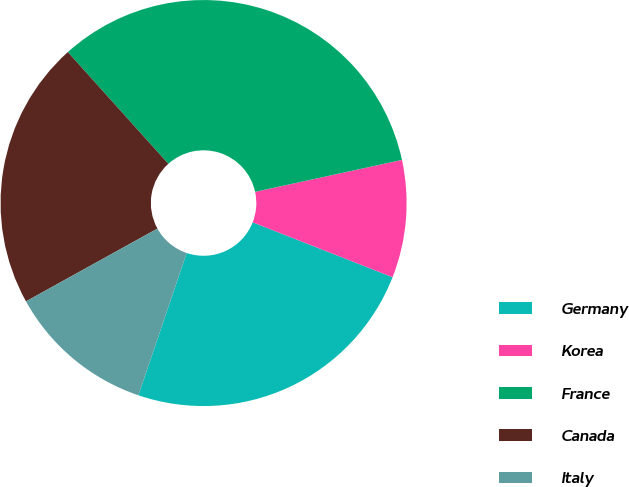Convert chart. <chart><loc_0><loc_0><loc_500><loc_500><pie_chart><fcel>Germany<fcel>Korea<fcel>France<fcel>Canada<fcel>Italy<nl><fcel>24.25%<fcel>9.36%<fcel>33.25%<fcel>21.39%<fcel>11.75%<nl></chart> 